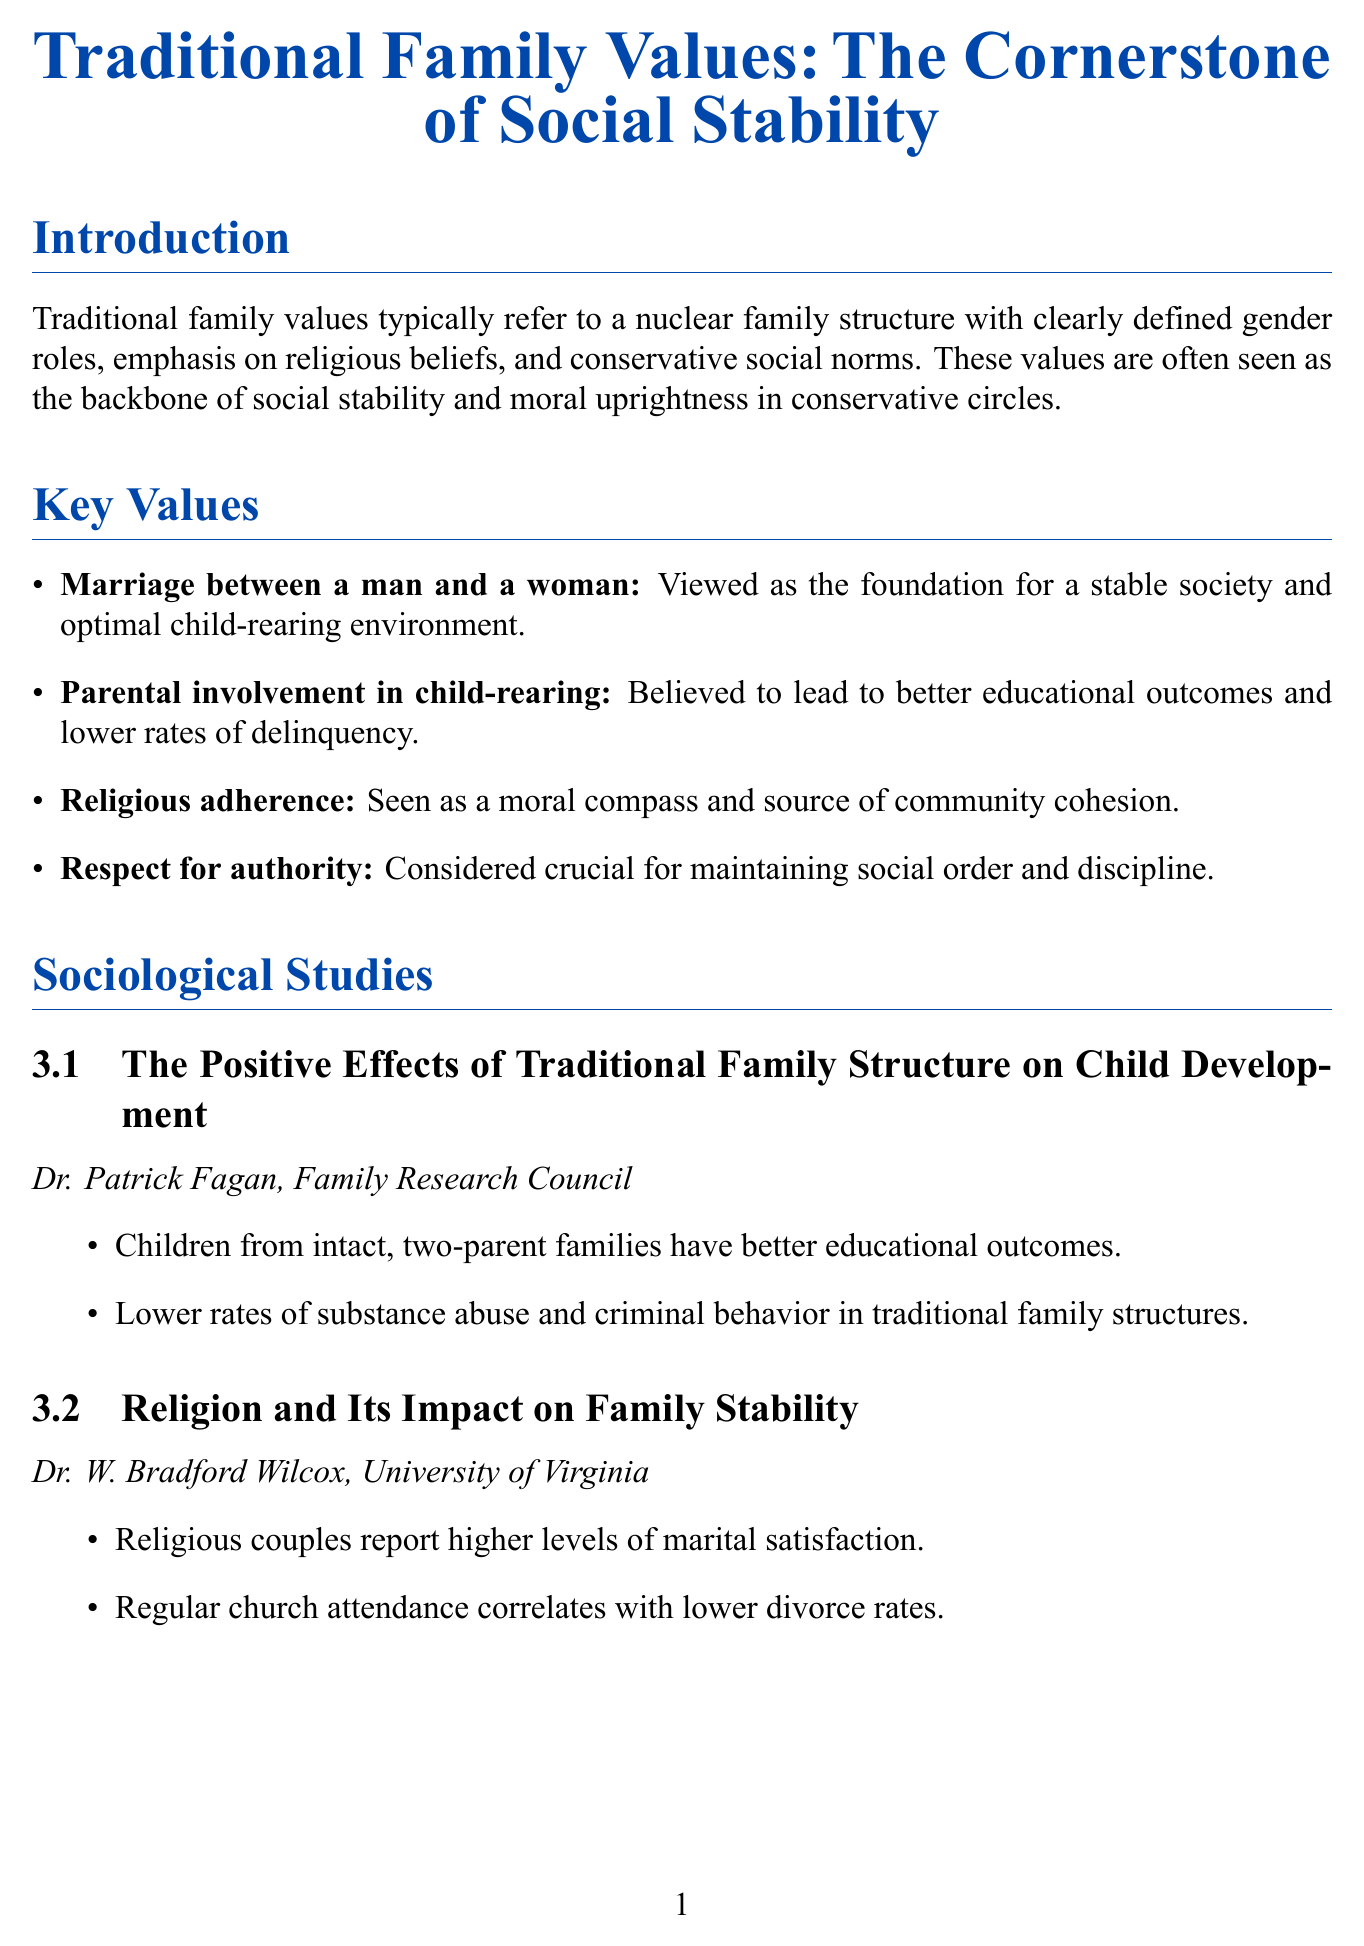What do traditional family values typically refer to? Traditional family values refer to a nuclear family structure with clearly defined gender roles, emphasis on religious beliefs, and conservative social norms.
Answer: A nuclear family structure What is considered the foundation for a stable society? Marriage between a man and a woman is viewed as the foundation for a stable society.
Answer: Marriage between a man and a woman Who authored "The Positive Effects of Traditional Family Structure on Child Development"? The author of the study is Dr. Patrick Fagan.
Answer: Dr. Patrick Fagan What do religious couples report according to Dr. W. Bradford Wilcox? Religious couples report higher levels of marital satisfaction.
Answer: Higher levels of marital satisfaction What are strong traditional families believed to contribute to? Strong traditional families are believed to contribute to economic stability and growth.
Answer: Economic stability and growth What is a perceived threat to traditional values? One perceived threat to traditional values is the legalization of same-sex marriage.
Answer: Same-sex marriage legalization Which organization advocates for religious freedom laws? The organization that advocates for religious freedom laws is part of the conservative responses section.
Answer: Conservative responses What is the main argument regarding the erosion of traditional family values? The main argument states that erosion of traditional family values leads to societal decay.
Answer: Societal decay What is the call to action mentioned in the conclusion? The call to action encourages listeners to support policies and organizations that promote traditional family structures and values.
Answer: Support policies and organizations 